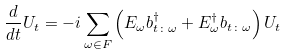Convert formula to latex. <formula><loc_0><loc_0><loc_500><loc_500>\frac { d } { d t } U _ { t } = - i \sum _ { \omega \in F } \left ( E _ { \omega } b ^ { \dagger } _ { t \colon \omega } + E ^ { \dagger } _ { \omega } b _ { t \colon \omega } \right ) U _ { t }</formula> 